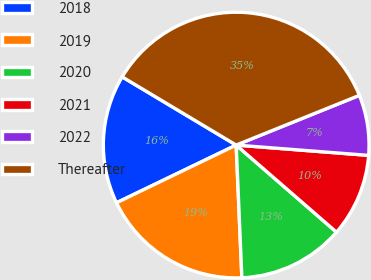Convert chart. <chart><loc_0><loc_0><loc_500><loc_500><pie_chart><fcel>2018<fcel>2019<fcel>2020<fcel>2021<fcel>2022<fcel>Thereafter<nl><fcel>15.73%<fcel>18.53%<fcel>12.94%<fcel>10.14%<fcel>7.34%<fcel>35.31%<nl></chart> 